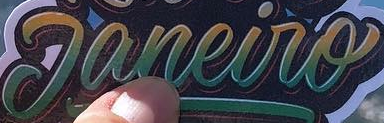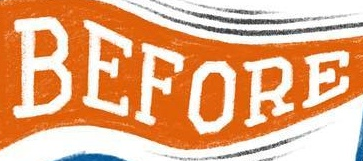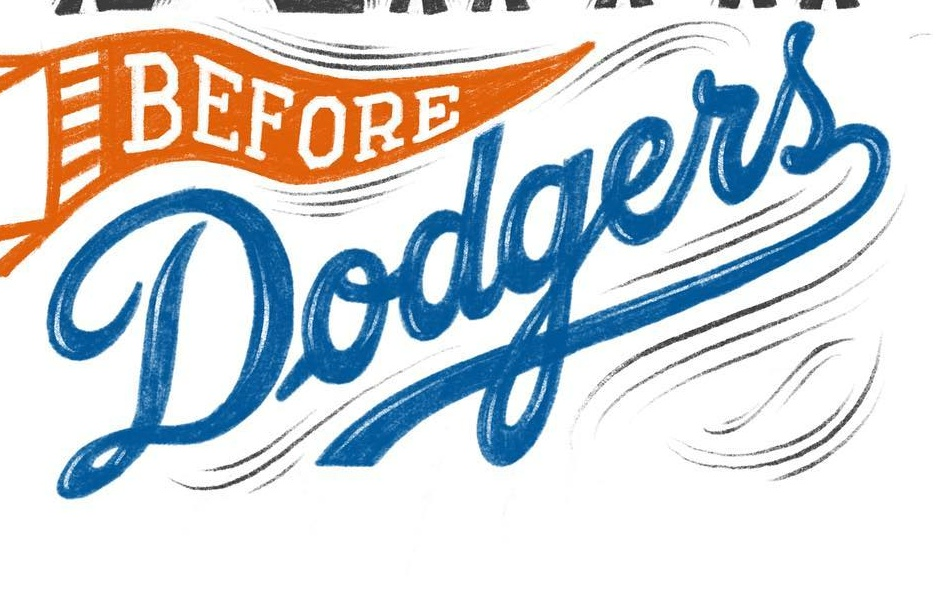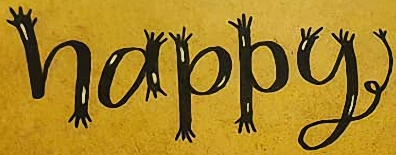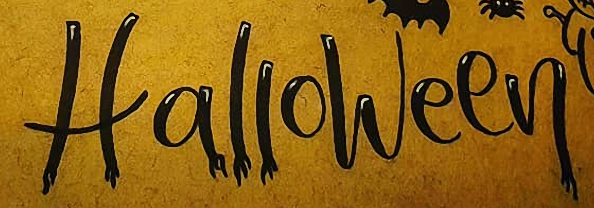Transcribe the words shown in these images in order, separated by a semicolon. Janeiro; BEFORE; Dodgers; happy; Halloween 